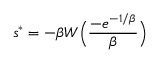Convert formula to latex. <formula><loc_0><loc_0><loc_500><loc_500>{ s ^ { * } } = - \beta W \left ( \frac { - e ^ { - 1 / \beta } } { \beta } \right )</formula> 